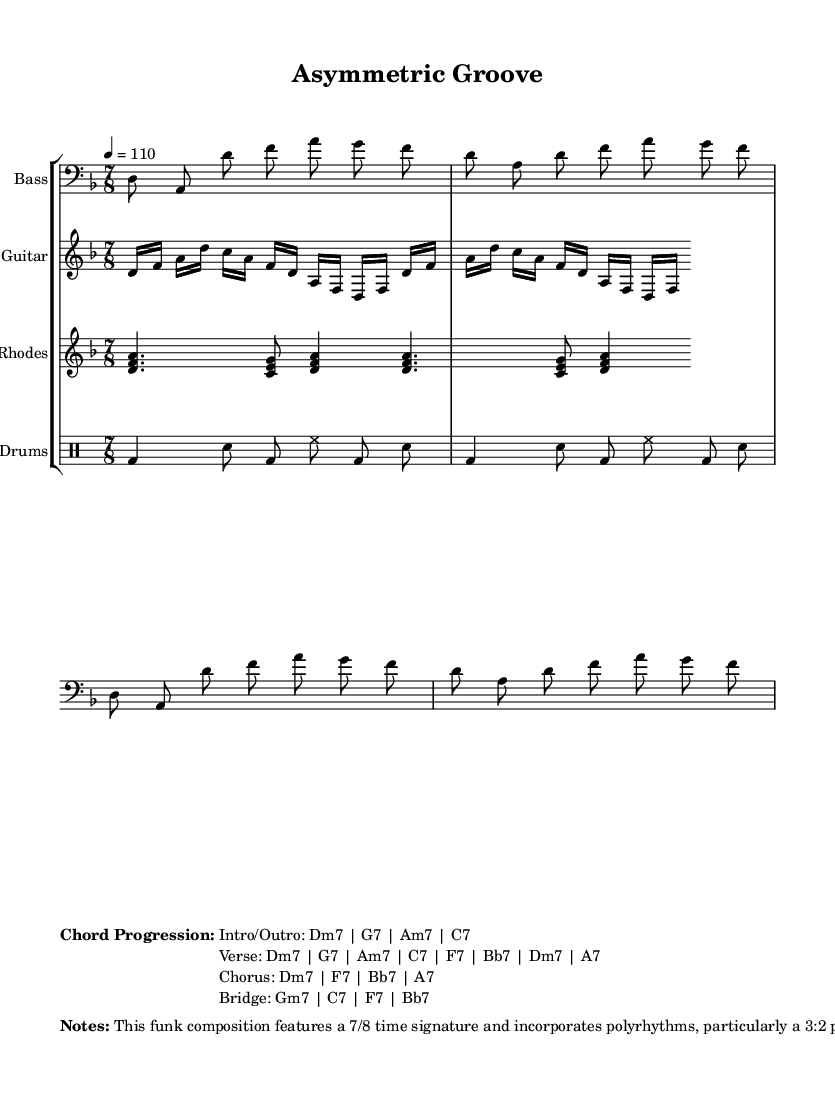What is the time signature of this music? The time signature is indicated at the beginning of the score. In this case, it shows 7/8, meaning there are seven eighth notes in each measure.
Answer: 7/8 What key is this piece composed in? The key signature is shown at the beginning of the score as well. It shows one flat, indicating that the piece is in the key of D minor.
Answer: D minor What is the tempo marking for this music? The tempo is defined in the score, and here it is marked as "4 = 110," which means there are 110 quarter notes per minute.
Answer: 110 Which instrument plays the bass line? The staff that contains the bass line is labeled with the instrument name "Bass" at the start. This clearly identifies the instrument that plays the noted part.
Answer: Bass Describe the rhythm pattern used in the drum groove. The drum groove section shows a repeat of certain rhythmic elements: bass drum, snare, and hi-hat, indicating a rhythmic combination and pattern that is common in funk. The pattern is structured with different note values to create complexity.
Answer: polyrhythm What polyrhythm is incorporated between guitar and bass? The musical notes and instructions indicate that a 3:2 polyrhythm is present during the bridge section, which is explicitly stated in the notes section below the main score. This indicates the rhythmic relationship between the guitar and bass parts.
Answer: 3:2 